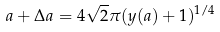Convert formula to latex. <formula><loc_0><loc_0><loc_500><loc_500>a + \Delta a = 4 \sqrt { 2 } \pi ( y ( a ) + 1 ) ^ { 1 / 4 }</formula> 